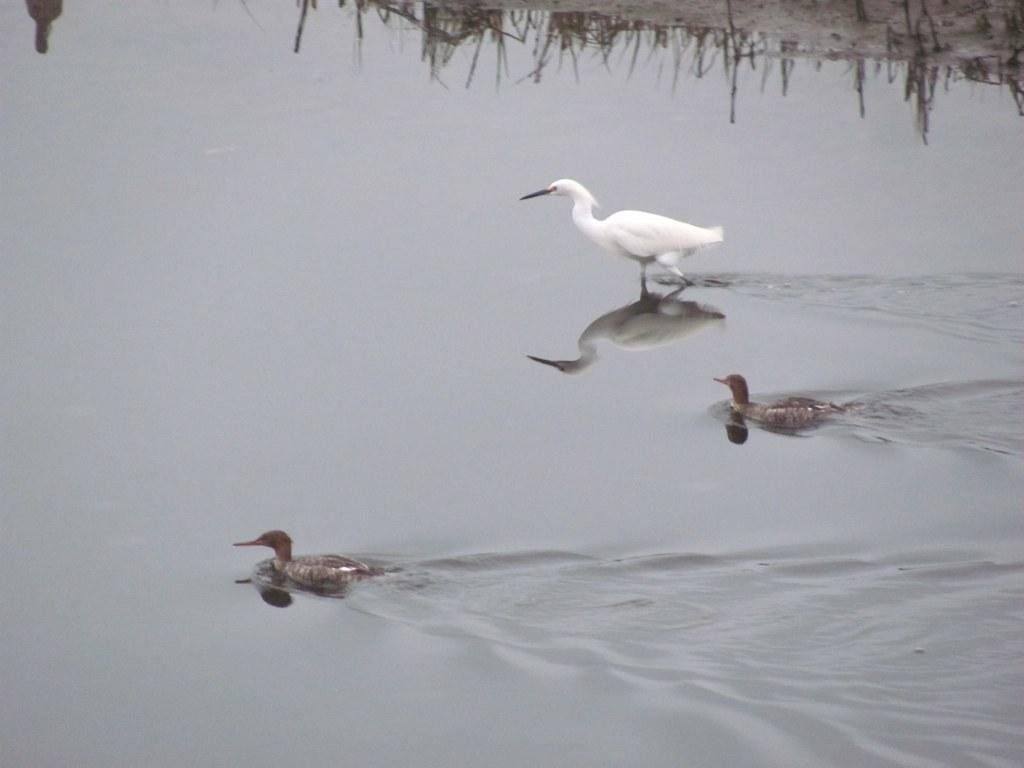What is visible in the image? Water is visible in the image. What type of animals can be seen in the image? There are three ducks in the image. What type of advice does the uncle give to the governor in the image? There is no uncle or governor present in the image, and therefore no such conversation can be observed. What type of angle is the angle of the image? The angle of the image cannot be determined from the image itself, as it is a description of the perspective from which the image was taken. 